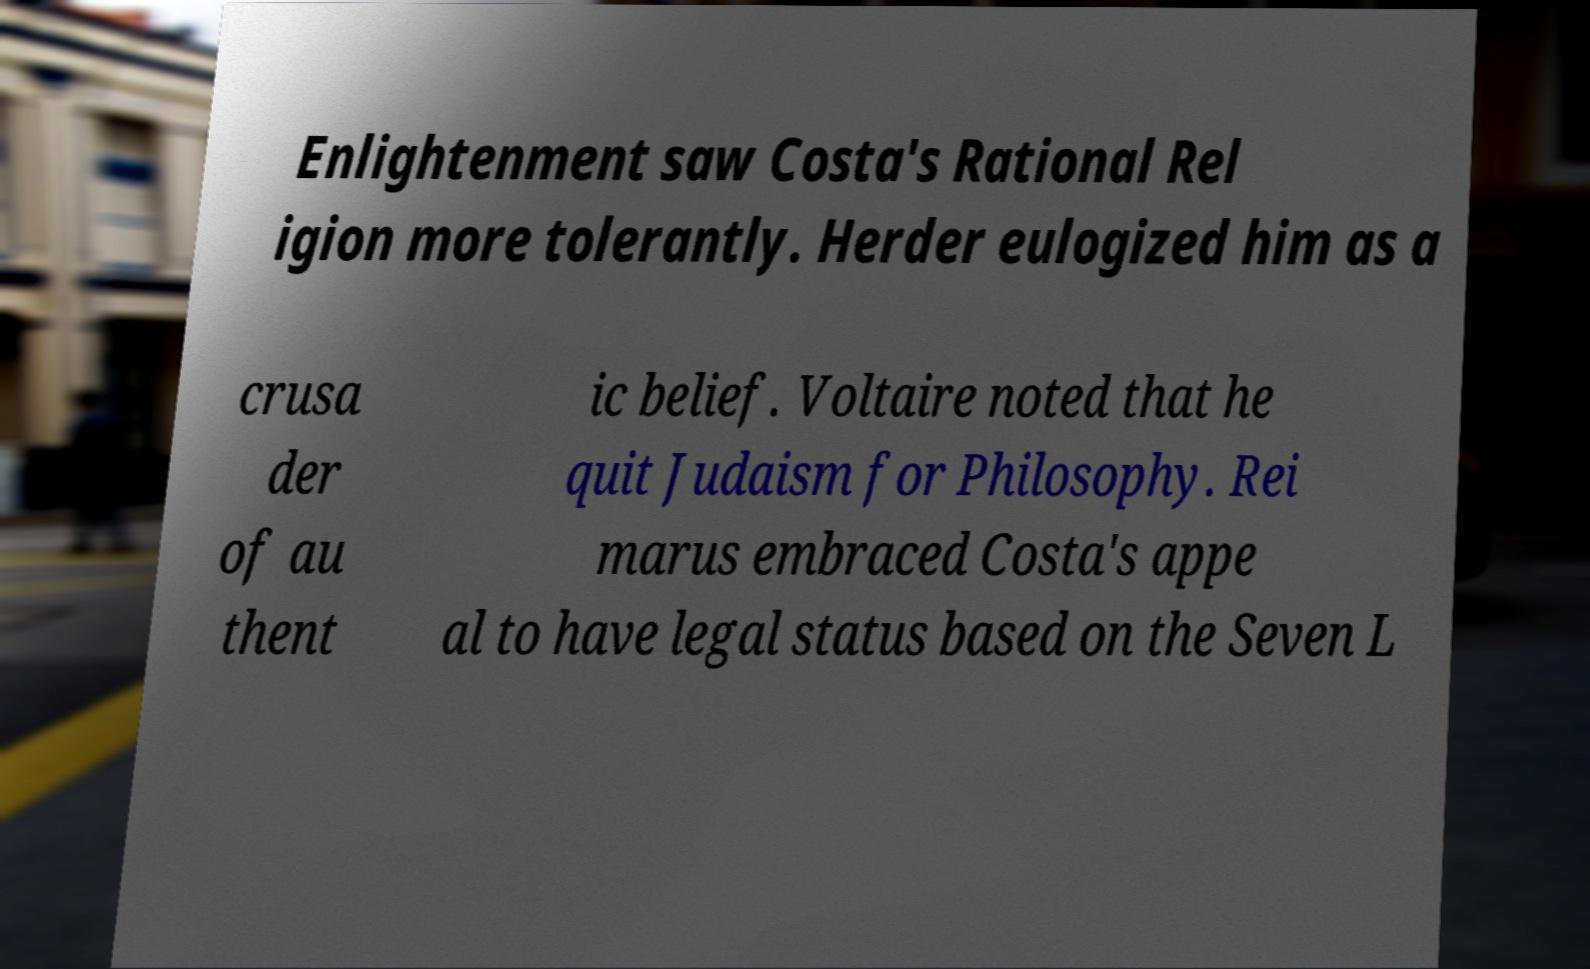What messages or text are displayed in this image? I need them in a readable, typed format. Enlightenment saw Costa's Rational Rel igion more tolerantly. Herder eulogized him as a crusa der of au thent ic belief. Voltaire noted that he quit Judaism for Philosophy. Rei marus embraced Costa's appe al to have legal status based on the Seven L 